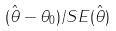Convert formula to latex. <formula><loc_0><loc_0><loc_500><loc_500>( \hat { \theta } - \theta _ { 0 } ) / S E ( \hat { \theta } )</formula> 